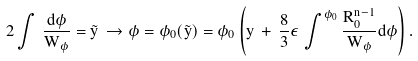<formula> <loc_0><loc_0><loc_500><loc_500>2 \int \, \frac { d \phi } { W _ { \phi } } = \tilde { y } \, \to \phi = \phi _ { 0 } ( \tilde { y } ) = \phi _ { 0 } \left ( y \, + \, \frac { 8 } { 3 } \epsilon \, \int ^ { \phi _ { 0 } } \frac { R _ { 0 } ^ { n - 1 } } { W _ { \phi } } d \phi \right ) .</formula> 